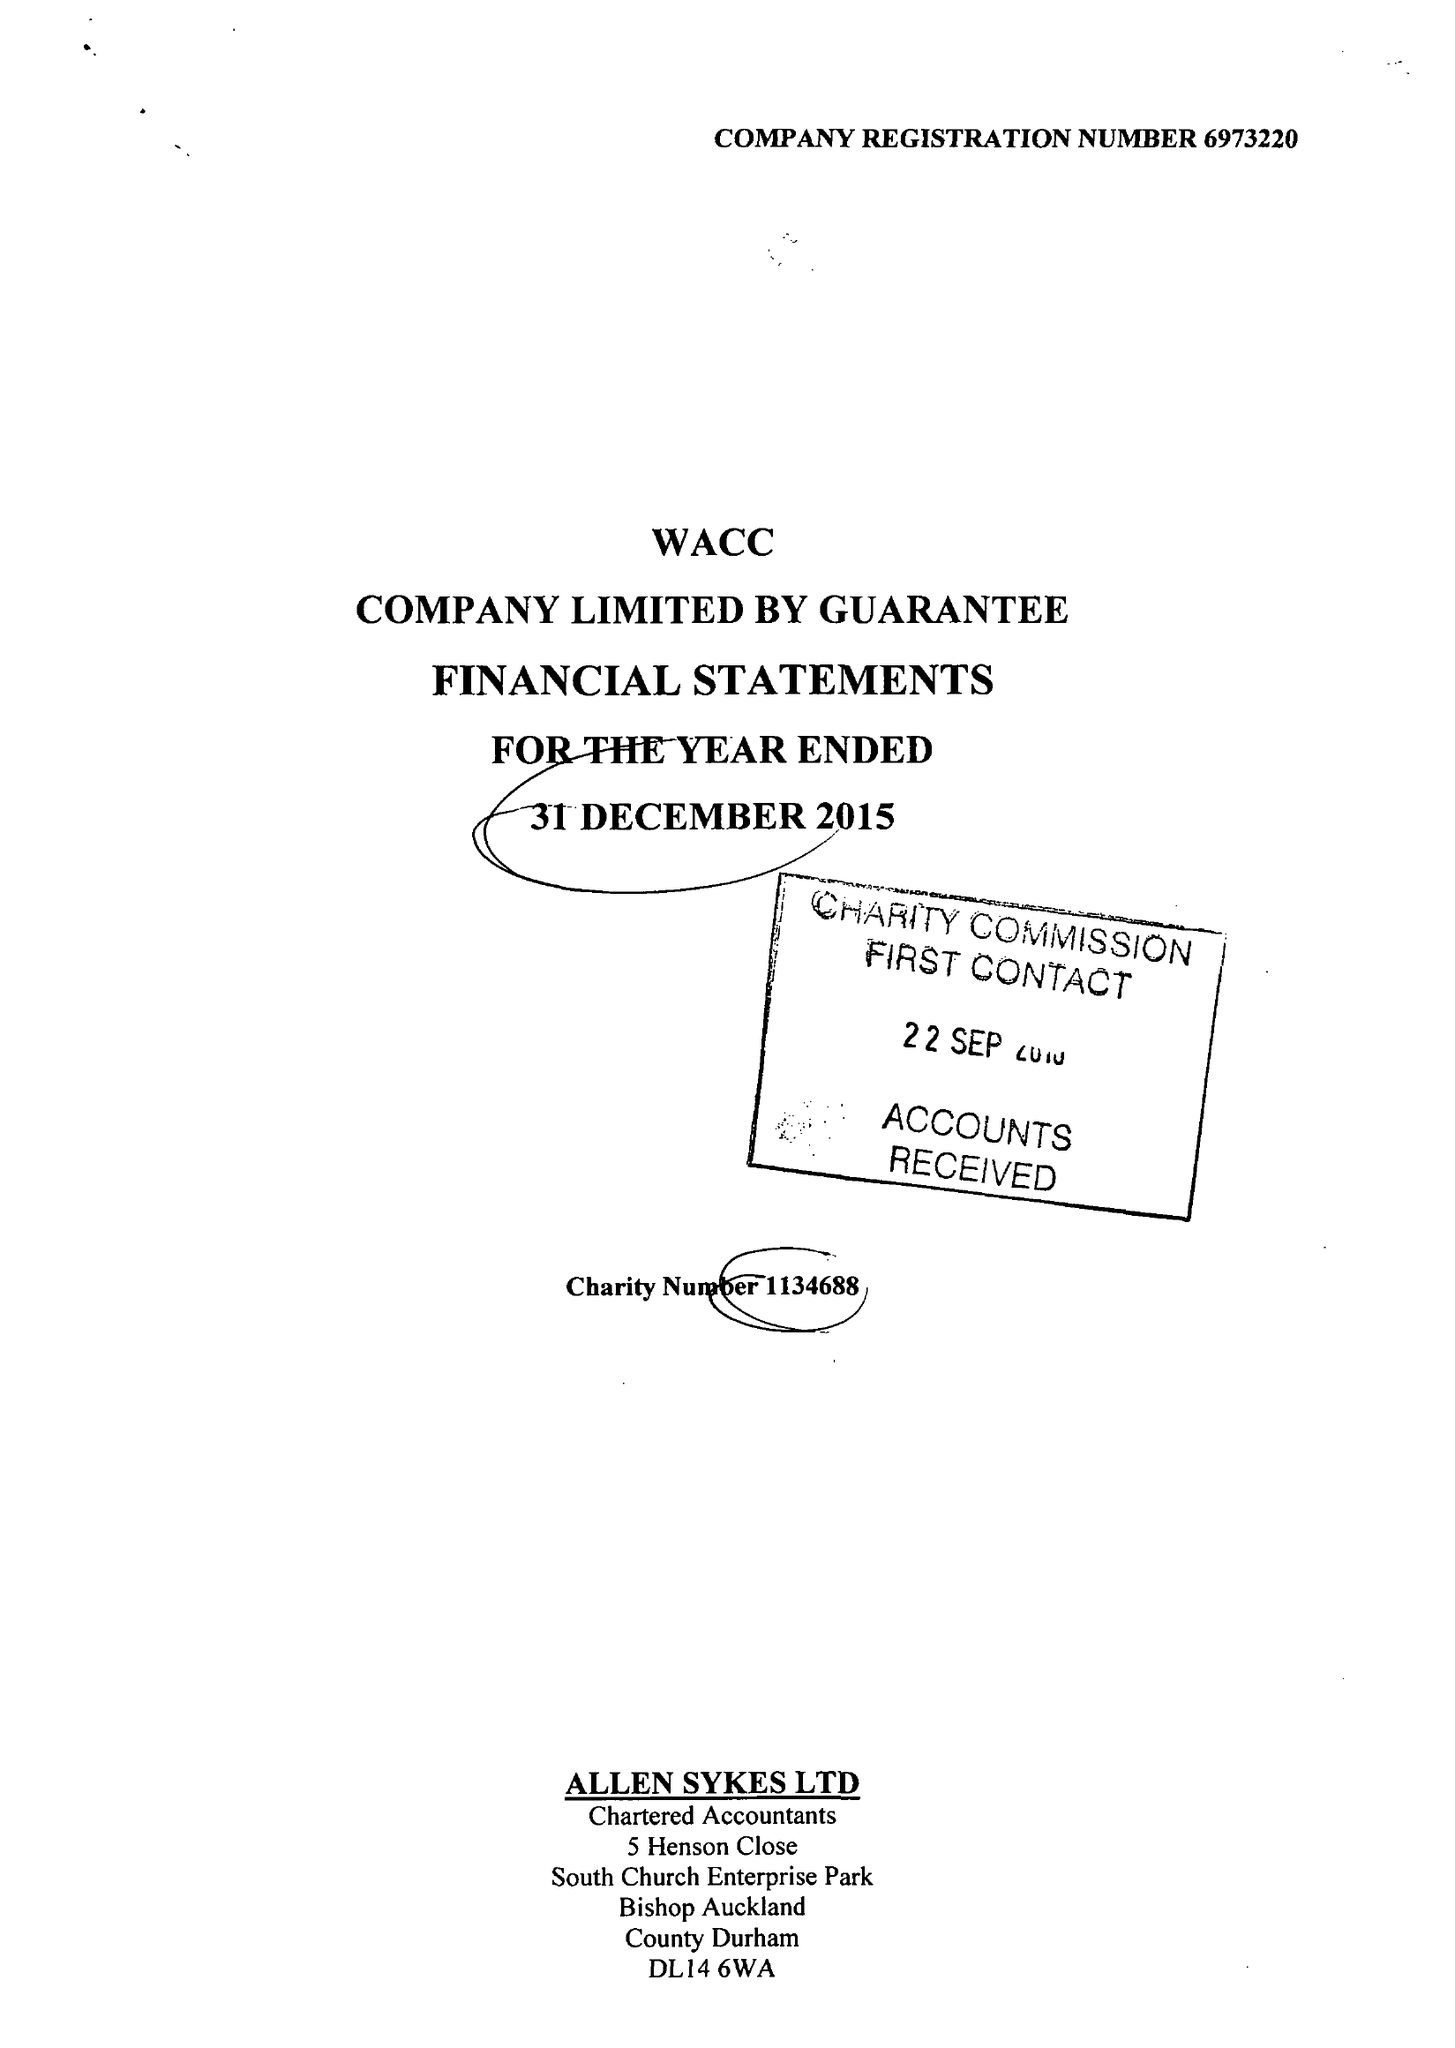What is the value for the address__postcode?
Answer the question using a single word or phrase. DL14 9HJ 